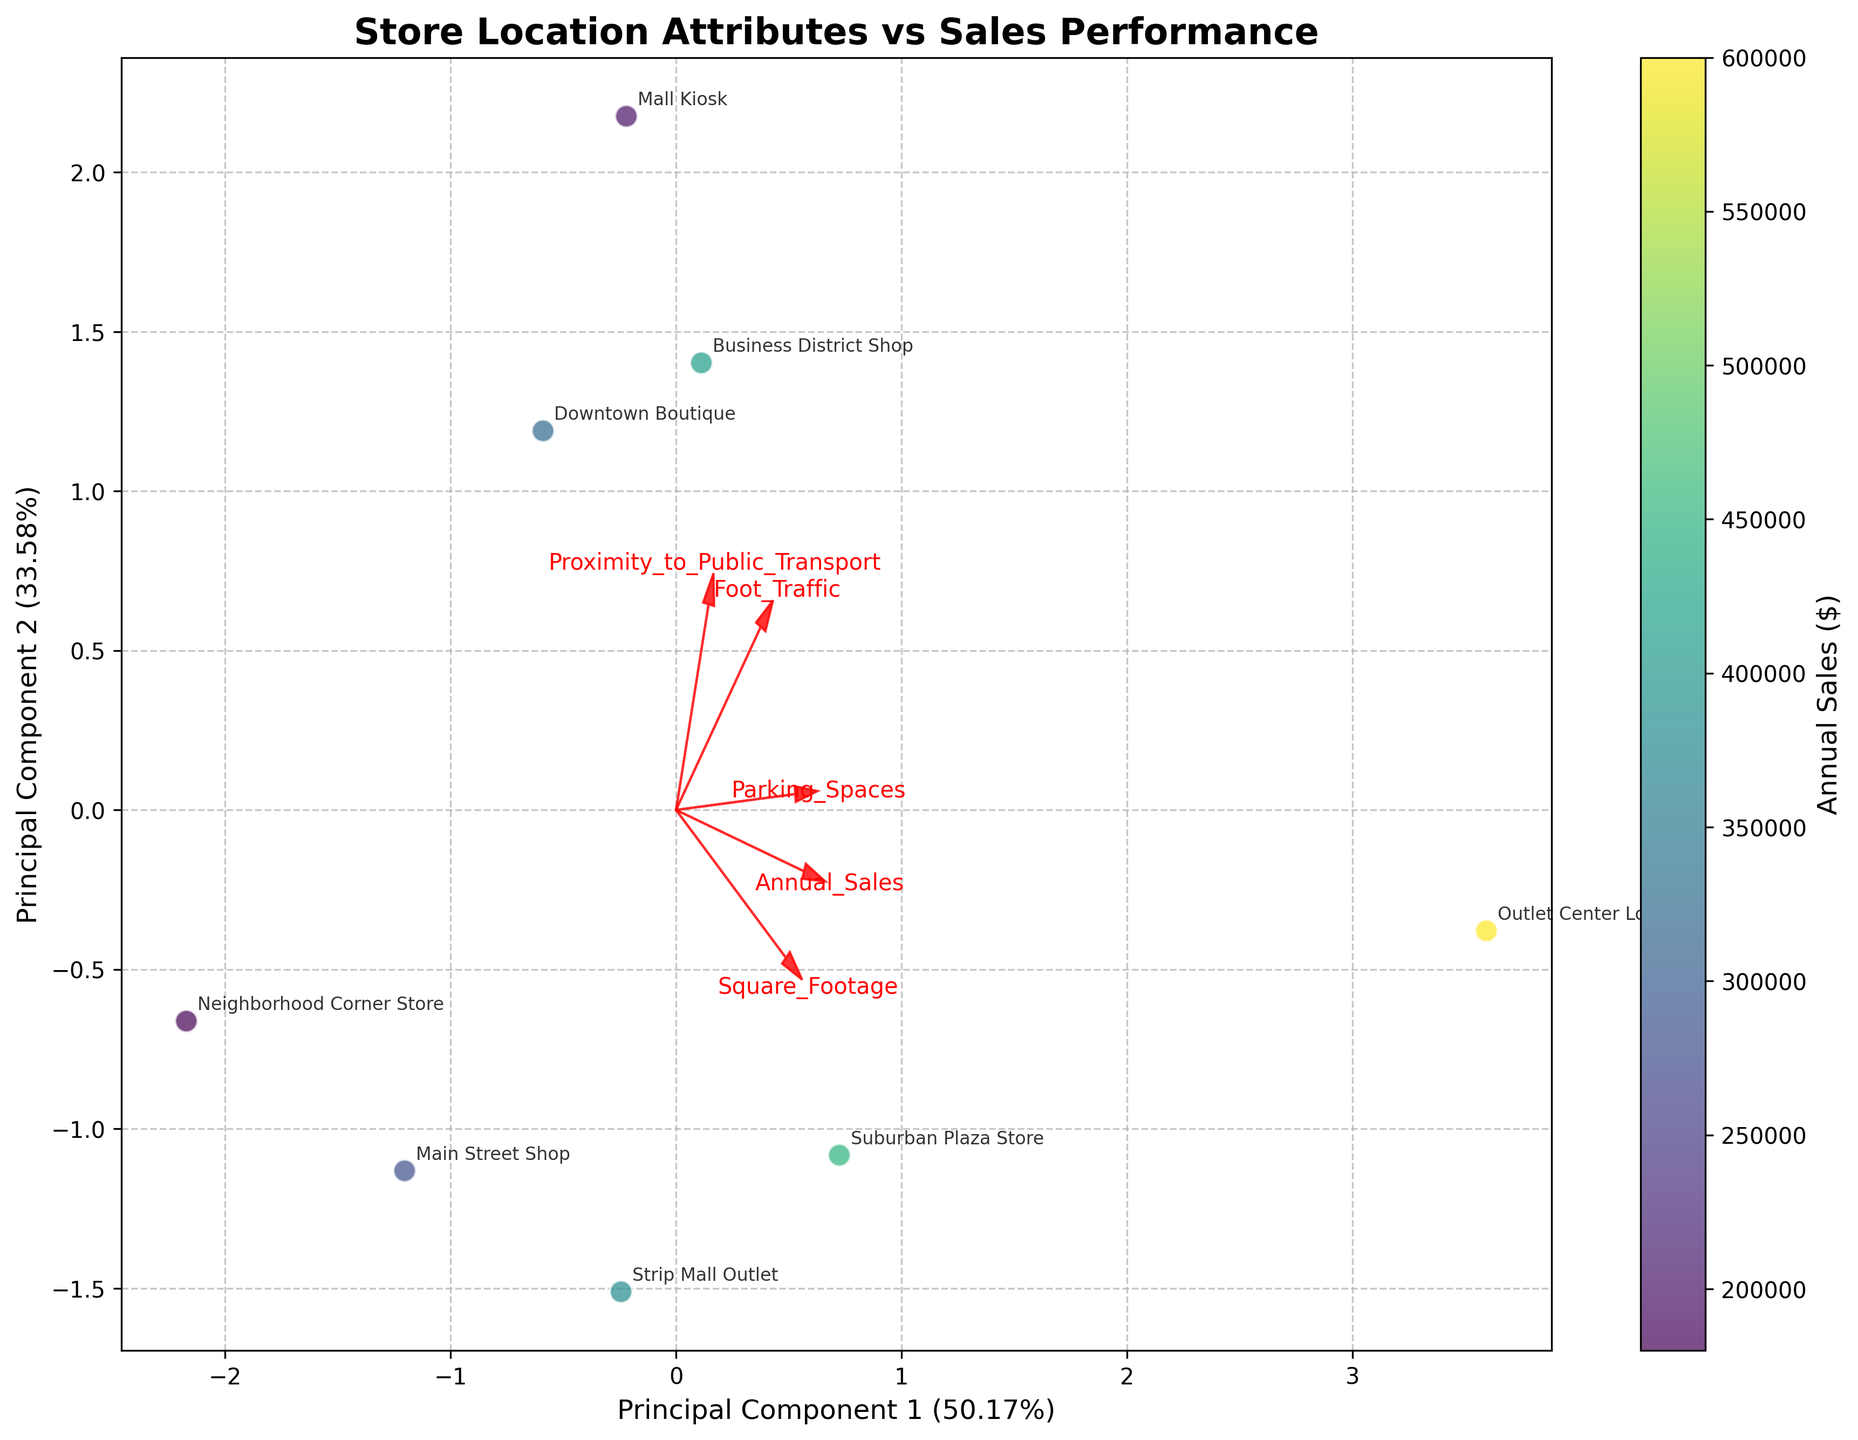What is the title of the plot? The title of the plot is located at the top-center of the figure. It is “Store Location Attributes vs Sales Performance”.
Answer: Store Location Attributes vs Sales Performance How many stores are represented in the plot? To determine the number of stores, count the number of labeled data points in the plot. There are eight labeled data points, each representing a store.
Answer: 8 Which principal component explains a higher percentage of variance in the data? The percentages explained by each principal component are shown on the x and y axis labels. Principal Component 1 explains a higher percentage of the variance at 41.98%, compared to Principal Component 2 at 30.68%.
Answer: Principal Component 1 Which feature vector appears to influence both principal components positively? Look at the direction of the red arrows (feature vectors). "Annual_Sales" has an arrow pointing positively for both principal components.
Answer: Annual_Sales Which store has the lowest projected PC1 value on the plot? Observe the positions of the data points along the PC1 axis. The "Neighborhood Corner Store" is positioned furthest to the left, indicating the lowest PC1 value.
Answer: Neighborhood Corner Store Between the "Downtown Boutique" and the "Business District Shop," which store experiences higher annual sales based on the plot? Use the color gradient representing annual sales. "Business District Shop" has a darker color, indicating higher annual sales compared to "Downtown Boutique."
Answer: Business District Shop Which feature seems to be the most positively correlated with annual sales? The feature with the arrow closest in direction to the gradient of the sales colors will be the most positively correlated. The feature vector for "Square_Footage" points in the same direction as the gradient for higher annual sales.
Answer: Square_Footage What is the position of the "Suburban Plaza Store" in terms of PC1 and PC2? Is it above or below the origin on the PC2 axis? Observe the location of the "Suburban Plaza Store" label. It is above the origin on the PC2 axis.
Answer: Above the origin on the PC2 axis Which store is closest to the origin in the plot? Find the data point nearest to the intersection of PC1 and PC2 axes (the origin). "Business District Shop" appears closest to the origin.
Answer: Business District Shop 